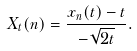<formula> <loc_0><loc_0><loc_500><loc_500>X _ { t } ( n ) = \frac { x _ { n } ( t ) - t } { - \sqrt { 2 t } } .</formula> 